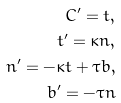<formula> <loc_0><loc_0><loc_500><loc_500>C ^ { \prime } = t , \\ t ^ { \prime } = \kappa n , \\ n ^ { \prime } = - \kappa t + \tau b , \\ b ^ { \prime } = - \tau n</formula> 